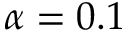<formula> <loc_0><loc_0><loc_500><loc_500>\alpha = 0 . 1</formula> 